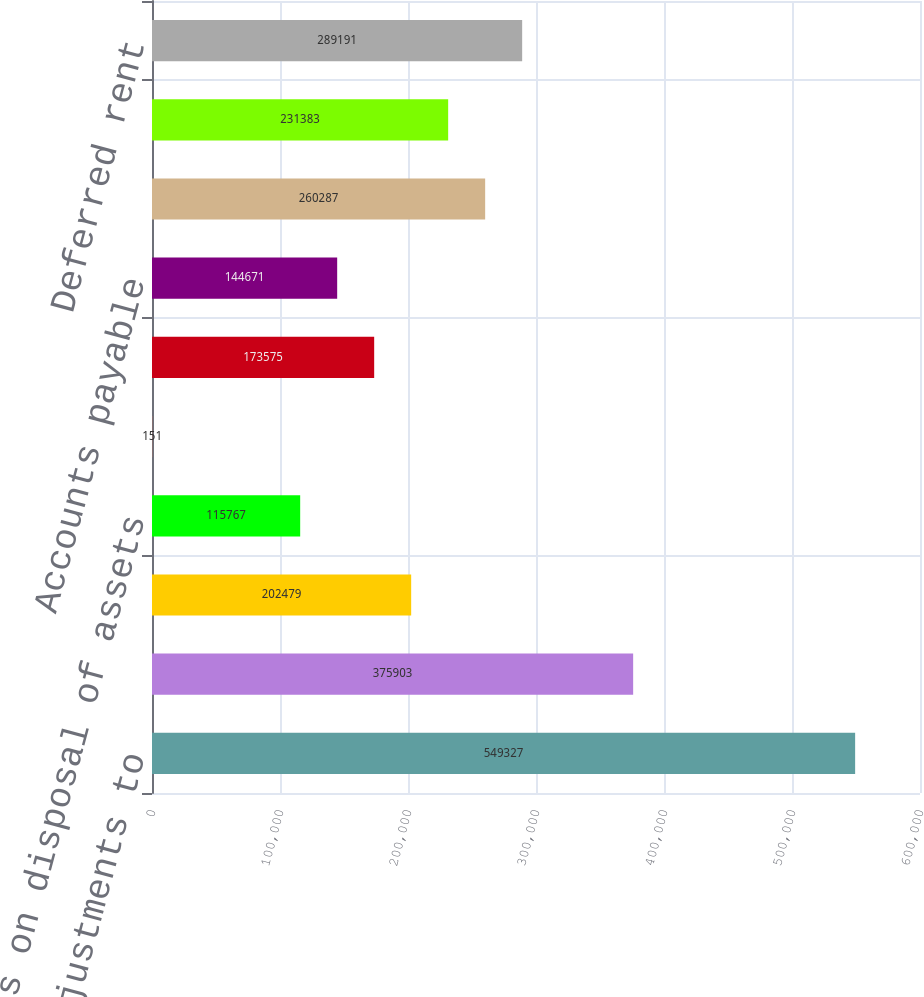<chart> <loc_0><loc_0><loc_500><loc_500><bar_chart><fcel>Net income Adjustments to<fcel>Depreciation and amortization<fcel>Deferred income tax provision<fcel>Loss on disposal of assets<fcel>Bad debt allowance<fcel>Other assets<fcel>Accounts payable<fcel>Accrued liabilities<fcel>Income tax payable/receivable<fcel>Deferred rent<nl><fcel>549327<fcel>375903<fcel>202479<fcel>115767<fcel>151<fcel>173575<fcel>144671<fcel>260287<fcel>231383<fcel>289191<nl></chart> 